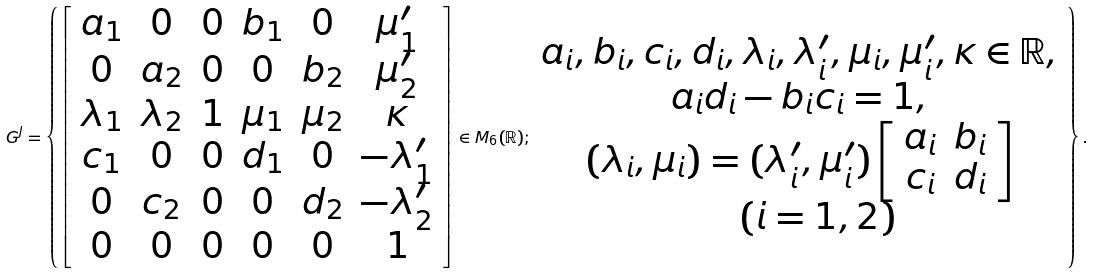Convert formula to latex. <formula><loc_0><loc_0><loc_500><loc_500>G ^ { J } = \left \{ \left [ \begin{array} { c c c c c c } a _ { 1 } & 0 & 0 & b _ { 1 } & 0 & \mu _ { 1 } ^ { \prime } \\ 0 & a _ { 2 } & 0 & 0 & b _ { 2 } & \mu _ { 2 } ^ { \prime } \\ \lambda _ { 1 } & \lambda _ { 2 } & 1 & \mu _ { 1 } & \mu _ { 2 } & \kappa \\ c _ { 1 } & 0 & 0 & d _ { 1 } & 0 & - \lambda _ { 1 } ^ { \prime } \\ 0 & c _ { 2 } & 0 & 0 & d _ { 2 } & - \lambda _ { 2 } ^ { \prime } \\ 0 & 0 & 0 & 0 & 0 & 1 \end{array} \right ] \in M _ { 6 } ( \mathbb { R } ) ; \begin{array} { c } a _ { i } , b _ { i } , c _ { i } , d _ { i } , \lambda _ { i } , \lambda _ { i } ^ { \prime } , \mu _ { i } , \mu _ { i } ^ { \prime } , \kappa \in \mathbb { R } , \\ a _ { i } d _ { i } - b _ { i } c _ { i } = 1 , \\ ( \lambda _ { i } , \mu _ { i } ) = ( \lambda _ { i } ^ { \prime } , \mu _ { i } ^ { \prime } ) \left [ \begin{array} { c c } a _ { i } & b _ { i } \\ c _ { i } & d _ { i } \end{array} \right ] \\ \quad ( i = 1 , 2 ) \end{array} \right \} .</formula> 